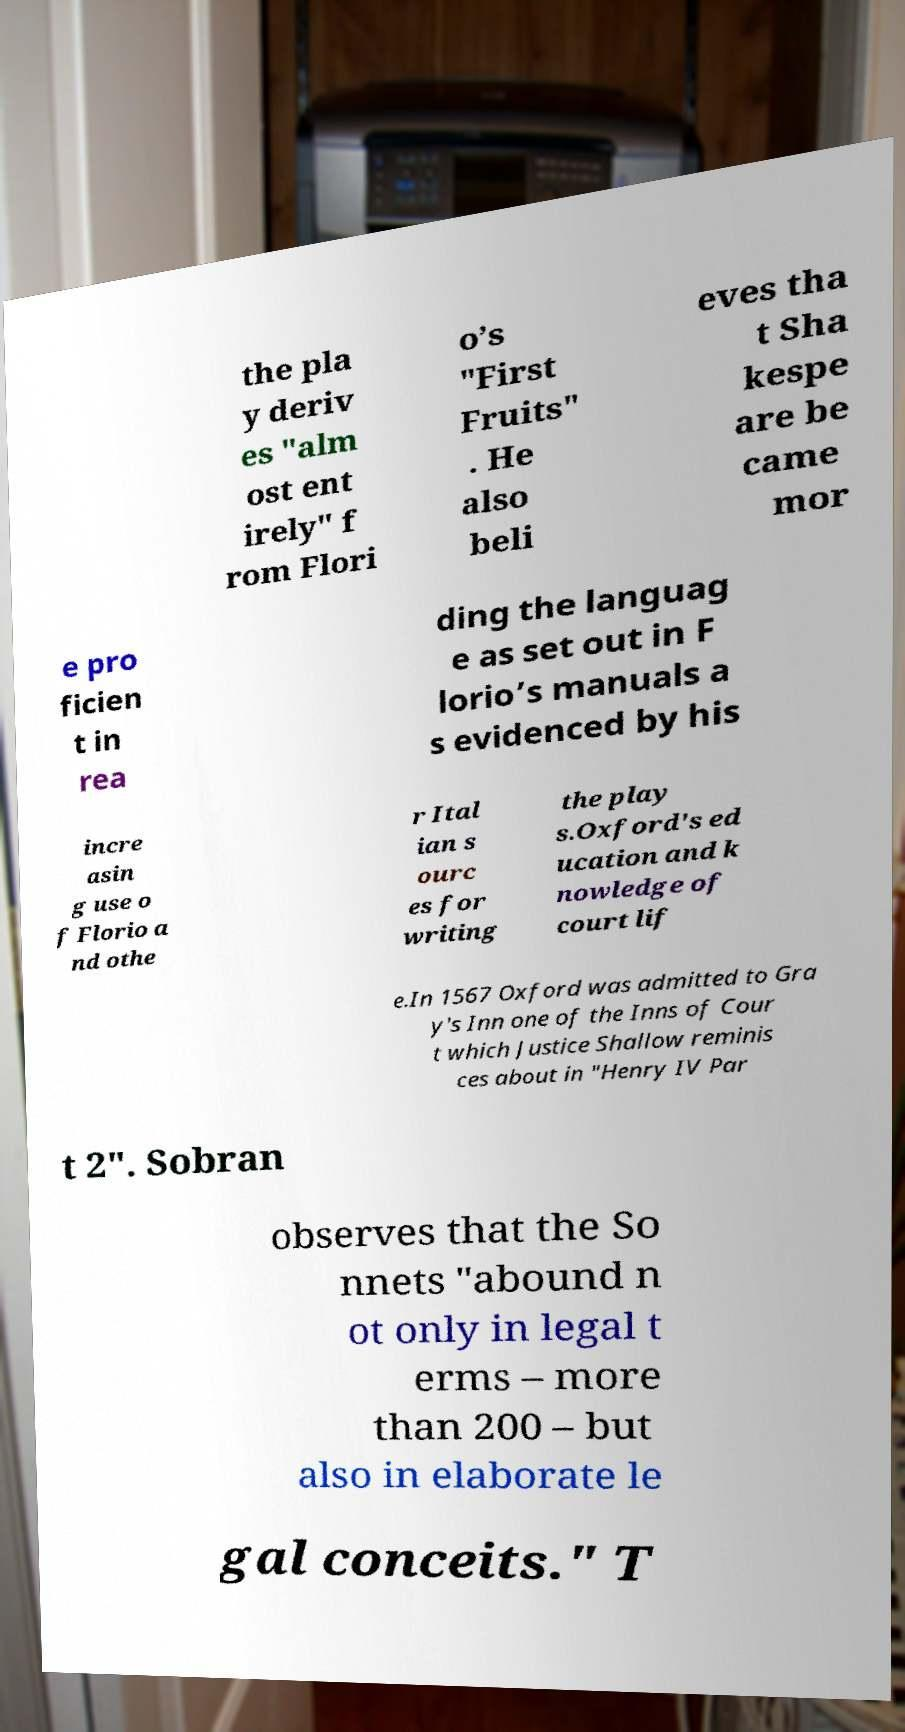Please identify and transcribe the text found in this image. the pla y deriv es "alm ost ent irely" f rom Flori o’s "First Fruits" . He also beli eves tha t Sha kespe are be came mor e pro ficien t in rea ding the languag e as set out in F lorio’s manuals a s evidenced by his incre asin g use o f Florio a nd othe r Ital ian s ourc es for writing the play s.Oxford's ed ucation and k nowledge of court lif e.In 1567 Oxford was admitted to Gra y's Inn one of the Inns of Cour t which Justice Shallow reminis ces about in "Henry IV Par t 2". Sobran observes that the So nnets "abound n ot only in legal t erms – more than 200 – but also in elaborate le gal conceits." T 